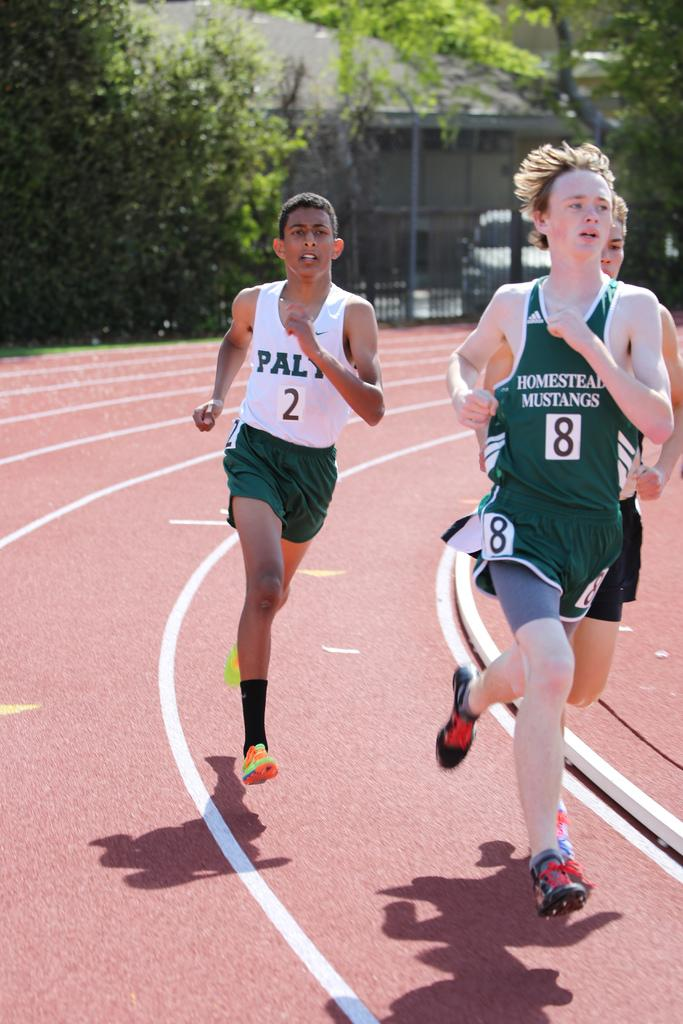What are the people in the image doing? The people in the image are running on the road. What can be observed about the road in the image? The road has painted lines. What is located near the road in the image? There is a fence in the image. What can be seen in the background of the image? There is a vehicle, trees, and a building in the background of the image. What type of question can be seen on the fence in the image? There is no question visible on the fence in the image. Can you see a mountain in the background of the image? There is no mountain present in the background of the image. 